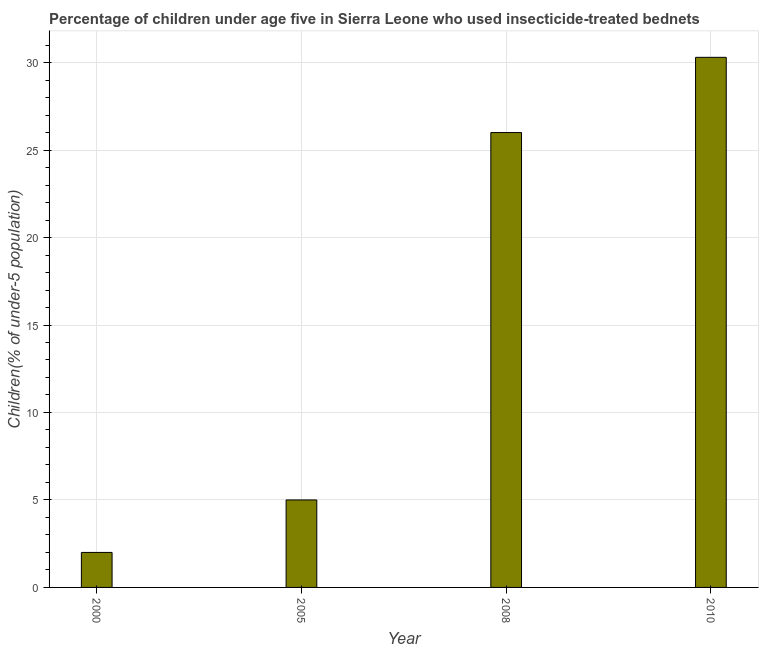Does the graph contain grids?
Your answer should be very brief. Yes. What is the title of the graph?
Your response must be concise. Percentage of children under age five in Sierra Leone who used insecticide-treated bednets. What is the label or title of the Y-axis?
Give a very brief answer. Children(% of under-5 population). Across all years, what is the maximum percentage of children who use of insecticide-treated bed nets?
Give a very brief answer. 30.3. Across all years, what is the minimum percentage of children who use of insecticide-treated bed nets?
Keep it short and to the point. 2. In which year was the percentage of children who use of insecticide-treated bed nets maximum?
Your answer should be compact. 2010. What is the sum of the percentage of children who use of insecticide-treated bed nets?
Offer a terse response. 63.3. What is the difference between the percentage of children who use of insecticide-treated bed nets in 2008 and 2010?
Make the answer very short. -4.3. What is the average percentage of children who use of insecticide-treated bed nets per year?
Provide a succinct answer. 15.82. What is the median percentage of children who use of insecticide-treated bed nets?
Your response must be concise. 15.5. In how many years, is the percentage of children who use of insecticide-treated bed nets greater than 28 %?
Give a very brief answer. 1. What is the ratio of the percentage of children who use of insecticide-treated bed nets in 2005 to that in 2008?
Keep it short and to the point. 0.19. Is the percentage of children who use of insecticide-treated bed nets in 2005 less than that in 2010?
Provide a short and direct response. Yes. Is the difference between the percentage of children who use of insecticide-treated bed nets in 2005 and 2008 greater than the difference between any two years?
Your response must be concise. No. What is the difference between the highest and the lowest percentage of children who use of insecticide-treated bed nets?
Your response must be concise. 28.3. In how many years, is the percentage of children who use of insecticide-treated bed nets greater than the average percentage of children who use of insecticide-treated bed nets taken over all years?
Give a very brief answer. 2. How many bars are there?
Give a very brief answer. 4. Are all the bars in the graph horizontal?
Ensure brevity in your answer.  No. What is the difference between two consecutive major ticks on the Y-axis?
Keep it short and to the point. 5. Are the values on the major ticks of Y-axis written in scientific E-notation?
Provide a succinct answer. No. What is the Children(% of under-5 population) of 2000?
Your answer should be compact. 2. What is the Children(% of under-5 population) in 2008?
Make the answer very short. 26. What is the Children(% of under-5 population) in 2010?
Keep it short and to the point. 30.3. What is the difference between the Children(% of under-5 population) in 2000 and 2005?
Give a very brief answer. -3. What is the difference between the Children(% of under-5 population) in 2000 and 2010?
Keep it short and to the point. -28.3. What is the difference between the Children(% of under-5 population) in 2005 and 2008?
Your answer should be very brief. -21. What is the difference between the Children(% of under-5 population) in 2005 and 2010?
Give a very brief answer. -25.3. What is the ratio of the Children(% of under-5 population) in 2000 to that in 2008?
Ensure brevity in your answer.  0.08. What is the ratio of the Children(% of under-5 population) in 2000 to that in 2010?
Your response must be concise. 0.07. What is the ratio of the Children(% of under-5 population) in 2005 to that in 2008?
Offer a terse response. 0.19. What is the ratio of the Children(% of under-5 population) in 2005 to that in 2010?
Provide a short and direct response. 0.17. What is the ratio of the Children(% of under-5 population) in 2008 to that in 2010?
Ensure brevity in your answer.  0.86. 